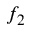<formula> <loc_0><loc_0><loc_500><loc_500>f _ { 2 }</formula> 